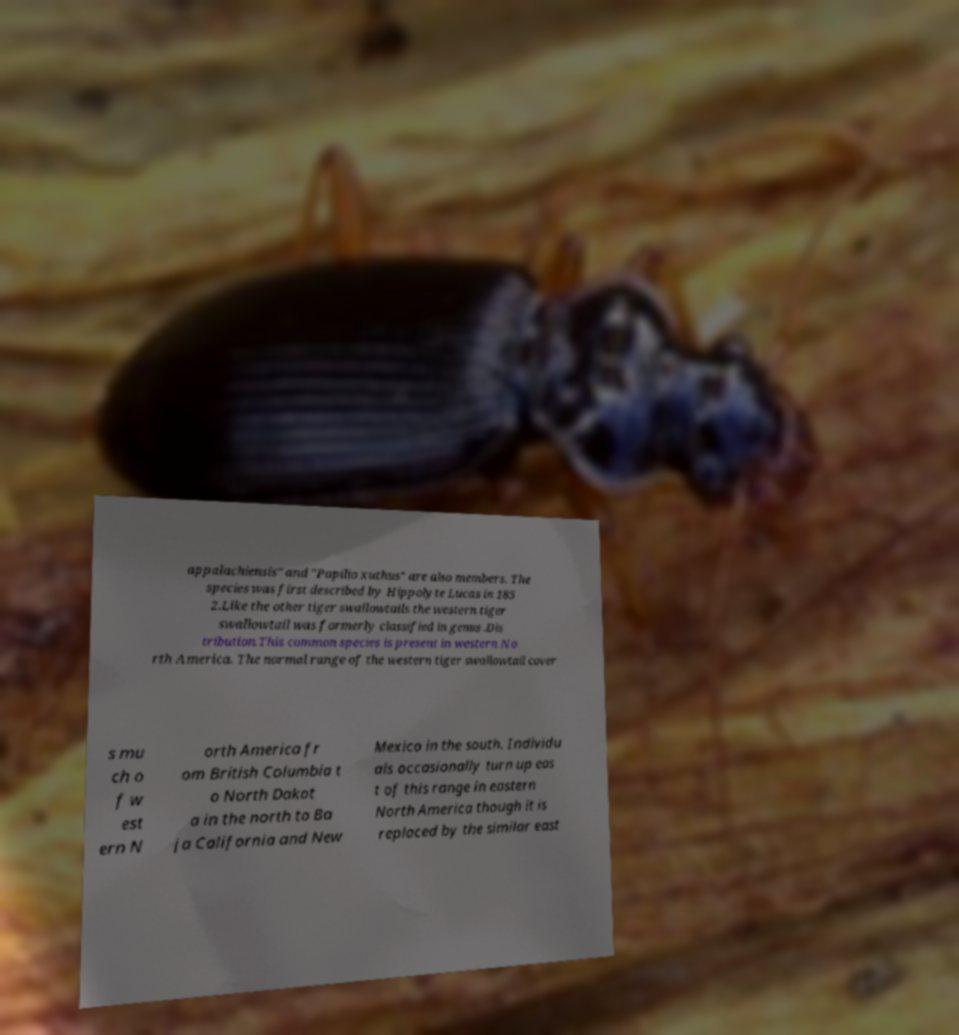Please identify and transcribe the text found in this image. appalachiensis" and "Papilio xuthus" are also members. The species was first described by Hippolyte Lucas in 185 2.Like the other tiger swallowtails the western tiger swallowtail was formerly classified in genus .Dis tribution.This common species is present in western No rth America. The normal range of the western tiger swallowtail cover s mu ch o f w est ern N orth America fr om British Columbia t o North Dakot a in the north to Ba ja California and New Mexico in the south. Individu als occasionally turn up eas t of this range in eastern North America though it is replaced by the similar east 